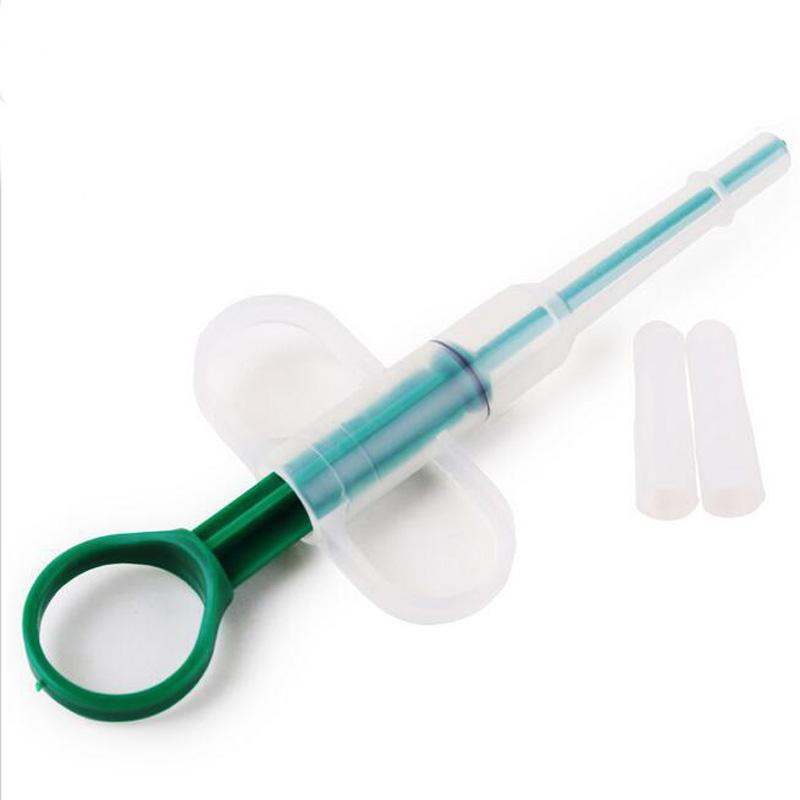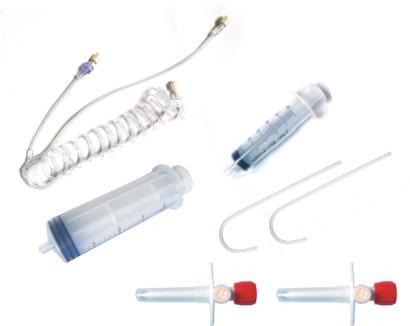The first image is the image on the left, the second image is the image on the right. For the images displayed, is the sentence "There are two pieces of flexible tubing in the image on the right." factually correct? Answer yes or no. Yes. 